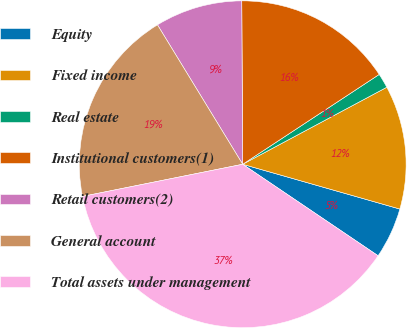Convert chart. <chart><loc_0><loc_0><loc_500><loc_500><pie_chart><fcel>Equity<fcel>Fixed income<fcel>Real estate<fcel>Institutional customers(1)<fcel>Retail customers(2)<fcel>General account<fcel>Total assets under management<nl><fcel>5.04%<fcel>12.23%<fcel>1.45%<fcel>15.83%<fcel>8.64%<fcel>19.42%<fcel>37.39%<nl></chart> 